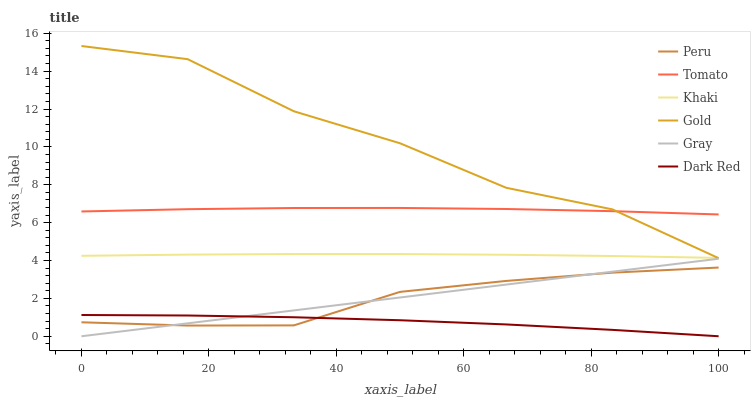Does Dark Red have the minimum area under the curve?
Answer yes or no. Yes. Does Gold have the maximum area under the curve?
Answer yes or no. Yes. Does Gray have the minimum area under the curve?
Answer yes or no. No. Does Gray have the maximum area under the curve?
Answer yes or no. No. Is Gray the smoothest?
Answer yes or no. Yes. Is Gold the roughest?
Answer yes or no. Yes. Is Khaki the smoothest?
Answer yes or no. No. Is Khaki the roughest?
Answer yes or no. No. Does Gray have the lowest value?
Answer yes or no. Yes. Does Khaki have the lowest value?
Answer yes or no. No. Does Gold have the highest value?
Answer yes or no. Yes. Does Gray have the highest value?
Answer yes or no. No. Is Gray less than Khaki?
Answer yes or no. Yes. Is Gold greater than Gray?
Answer yes or no. Yes. Does Gray intersect Dark Red?
Answer yes or no. Yes. Is Gray less than Dark Red?
Answer yes or no. No. Is Gray greater than Dark Red?
Answer yes or no. No. Does Gray intersect Khaki?
Answer yes or no. No. 